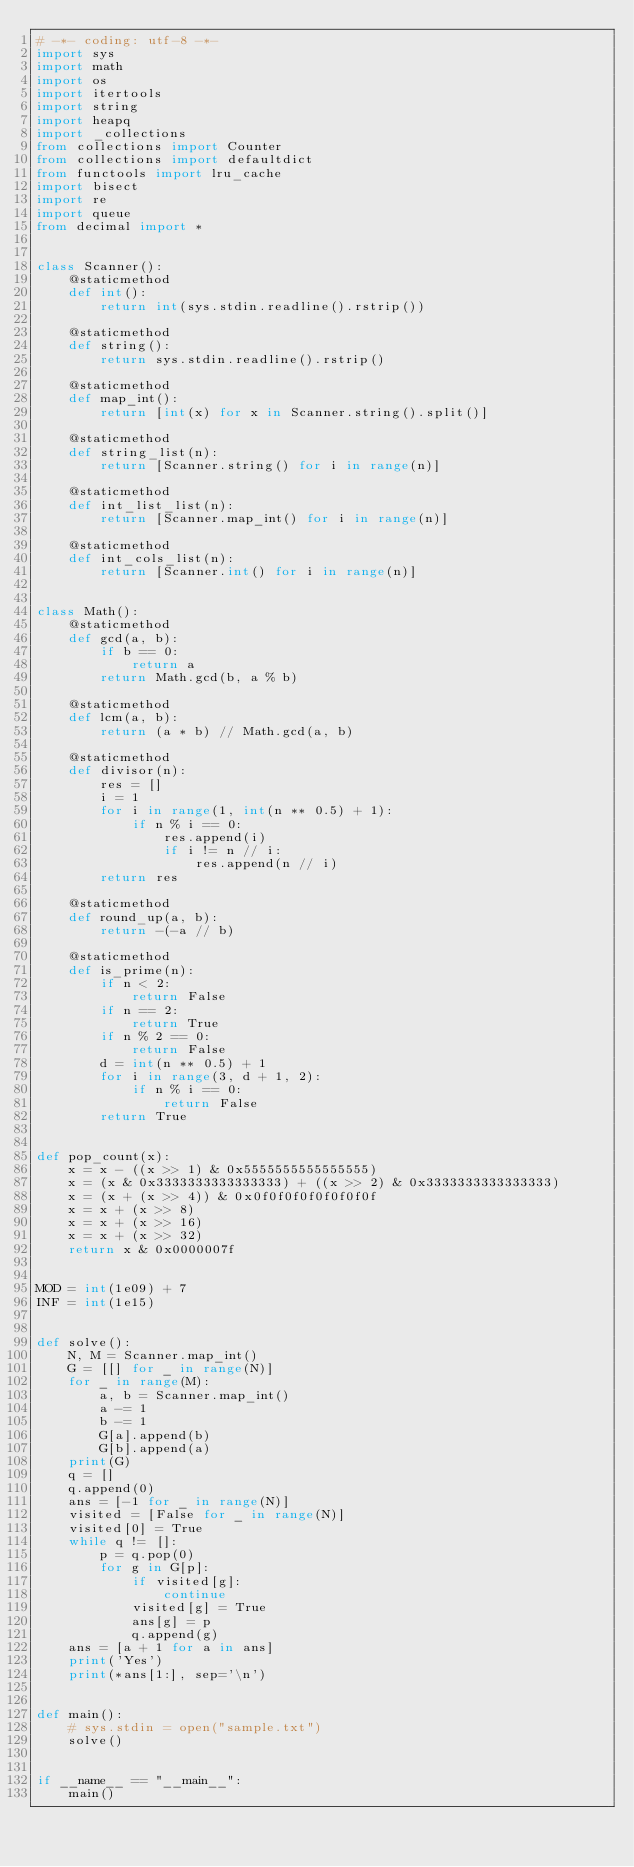<code> <loc_0><loc_0><loc_500><loc_500><_Python_># -*- coding: utf-8 -*-
import sys
import math
import os
import itertools
import string
import heapq
import _collections
from collections import Counter
from collections import defaultdict
from functools import lru_cache
import bisect
import re
import queue
from decimal import *


class Scanner():
    @staticmethod
    def int():
        return int(sys.stdin.readline().rstrip())

    @staticmethod
    def string():
        return sys.stdin.readline().rstrip()

    @staticmethod
    def map_int():
        return [int(x) for x in Scanner.string().split()]

    @staticmethod
    def string_list(n):
        return [Scanner.string() for i in range(n)]

    @staticmethod
    def int_list_list(n):
        return [Scanner.map_int() for i in range(n)]

    @staticmethod
    def int_cols_list(n):
        return [Scanner.int() for i in range(n)]


class Math():
    @staticmethod
    def gcd(a, b):
        if b == 0:
            return a
        return Math.gcd(b, a % b)

    @staticmethod
    def lcm(a, b):
        return (a * b) // Math.gcd(a, b)

    @staticmethod
    def divisor(n):
        res = []
        i = 1
        for i in range(1, int(n ** 0.5) + 1):
            if n % i == 0:
                res.append(i)
                if i != n // i:
                    res.append(n // i)
        return res

    @staticmethod
    def round_up(a, b):
        return -(-a // b)

    @staticmethod
    def is_prime(n):
        if n < 2:
            return False
        if n == 2:
            return True
        if n % 2 == 0:
            return False
        d = int(n ** 0.5) + 1
        for i in range(3, d + 1, 2):
            if n % i == 0:
                return False
        return True


def pop_count(x):
    x = x - ((x >> 1) & 0x5555555555555555)
    x = (x & 0x3333333333333333) + ((x >> 2) & 0x3333333333333333)
    x = (x + (x >> 4)) & 0x0f0f0f0f0f0f0f0f
    x = x + (x >> 8)
    x = x + (x >> 16)
    x = x + (x >> 32)
    return x & 0x0000007f


MOD = int(1e09) + 7
INF = int(1e15)


def solve():
    N, M = Scanner.map_int()
    G = [[] for _ in range(N)]
    for _ in range(M):
        a, b = Scanner.map_int()
        a -= 1
        b -= 1
        G[a].append(b)
        G[b].append(a)
    print(G)
    q = []
    q.append(0)
    ans = [-1 for _ in range(N)]
    visited = [False for _ in range(N)]
    visited[0] = True
    while q != []:
        p = q.pop(0)
        for g in G[p]:
            if visited[g]:
                continue
            visited[g] = True
            ans[g] = p
            q.append(g)
    ans = [a + 1 for a in ans]
    print('Yes')
    print(*ans[1:], sep='\n')


def main():
    # sys.stdin = open("sample.txt")
    solve()


if __name__ == "__main__":
    main()
</code> 